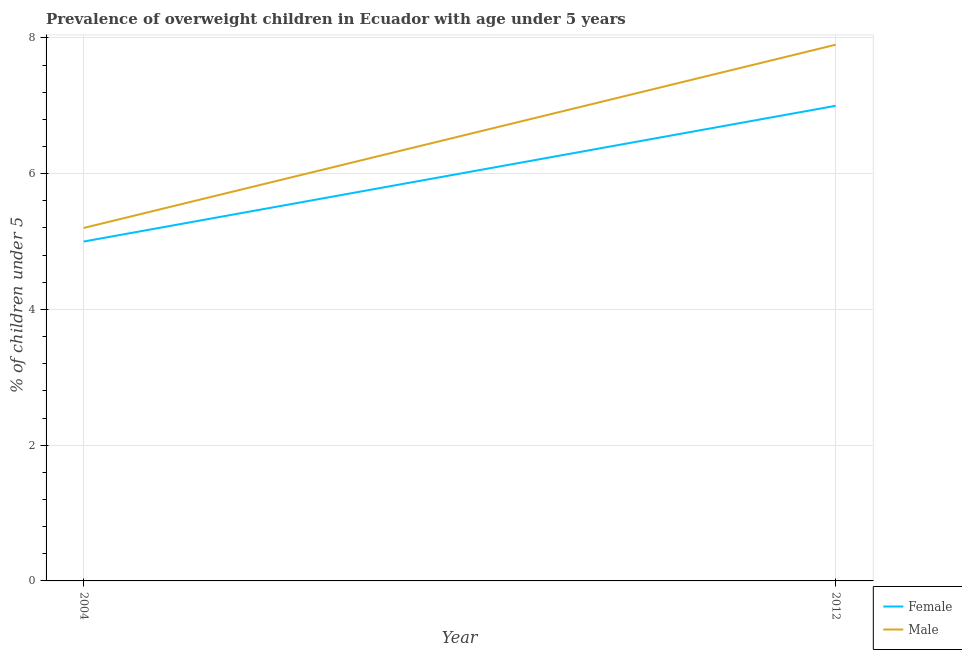How many different coloured lines are there?
Your answer should be very brief. 2. Is the number of lines equal to the number of legend labels?
Provide a short and direct response. Yes. What is the percentage of obese female children in 2004?
Your answer should be very brief. 5. Across all years, what is the maximum percentage of obese female children?
Ensure brevity in your answer.  7. Across all years, what is the minimum percentage of obese male children?
Offer a very short reply. 5.2. In which year was the percentage of obese female children maximum?
Give a very brief answer. 2012. In which year was the percentage of obese male children minimum?
Make the answer very short. 2004. What is the total percentage of obese female children in the graph?
Provide a succinct answer. 12. What is the difference between the percentage of obese female children in 2004 and that in 2012?
Your answer should be compact. -2. What is the difference between the percentage of obese male children in 2012 and the percentage of obese female children in 2004?
Your answer should be very brief. 2.9. What is the average percentage of obese female children per year?
Make the answer very short. 6. In the year 2004, what is the difference between the percentage of obese female children and percentage of obese male children?
Your answer should be compact. -0.2. In how many years, is the percentage of obese female children greater than 3.6 %?
Your answer should be compact. 2. What is the ratio of the percentage of obese male children in 2004 to that in 2012?
Your answer should be compact. 0.66. Does the percentage of obese male children monotonically increase over the years?
Keep it short and to the point. Yes. Is the percentage of obese female children strictly greater than the percentage of obese male children over the years?
Provide a succinct answer. No. Are the values on the major ticks of Y-axis written in scientific E-notation?
Keep it short and to the point. No. Does the graph contain grids?
Your response must be concise. Yes. Where does the legend appear in the graph?
Give a very brief answer. Bottom right. How many legend labels are there?
Your answer should be very brief. 2. How are the legend labels stacked?
Make the answer very short. Vertical. What is the title of the graph?
Provide a short and direct response. Prevalence of overweight children in Ecuador with age under 5 years. What is the label or title of the X-axis?
Provide a short and direct response. Year. What is the label or title of the Y-axis?
Keep it short and to the point.  % of children under 5. What is the  % of children under 5 of Female in 2004?
Make the answer very short. 5. What is the  % of children under 5 in Male in 2004?
Your answer should be very brief. 5.2. What is the  % of children under 5 of Female in 2012?
Make the answer very short. 7. What is the  % of children under 5 in Male in 2012?
Offer a terse response. 7.9. Across all years, what is the maximum  % of children under 5 in Male?
Provide a short and direct response. 7.9. Across all years, what is the minimum  % of children under 5 in Male?
Offer a terse response. 5.2. What is the total  % of children under 5 in Female in the graph?
Provide a short and direct response. 12. What is the average  % of children under 5 in Male per year?
Your response must be concise. 6.55. What is the ratio of the  % of children under 5 of Female in 2004 to that in 2012?
Give a very brief answer. 0.71. What is the ratio of the  % of children under 5 in Male in 2004 to that in 2012?
Keep it short and to the point. 0.66. What is the difference between the highest and the second highest  % of children under 5 of Female?
Provide a succinct answer. 2. What is the difference between the highest and the lowest  % of children under 5 in Male?
Provide a short and direct response. 2.7. 